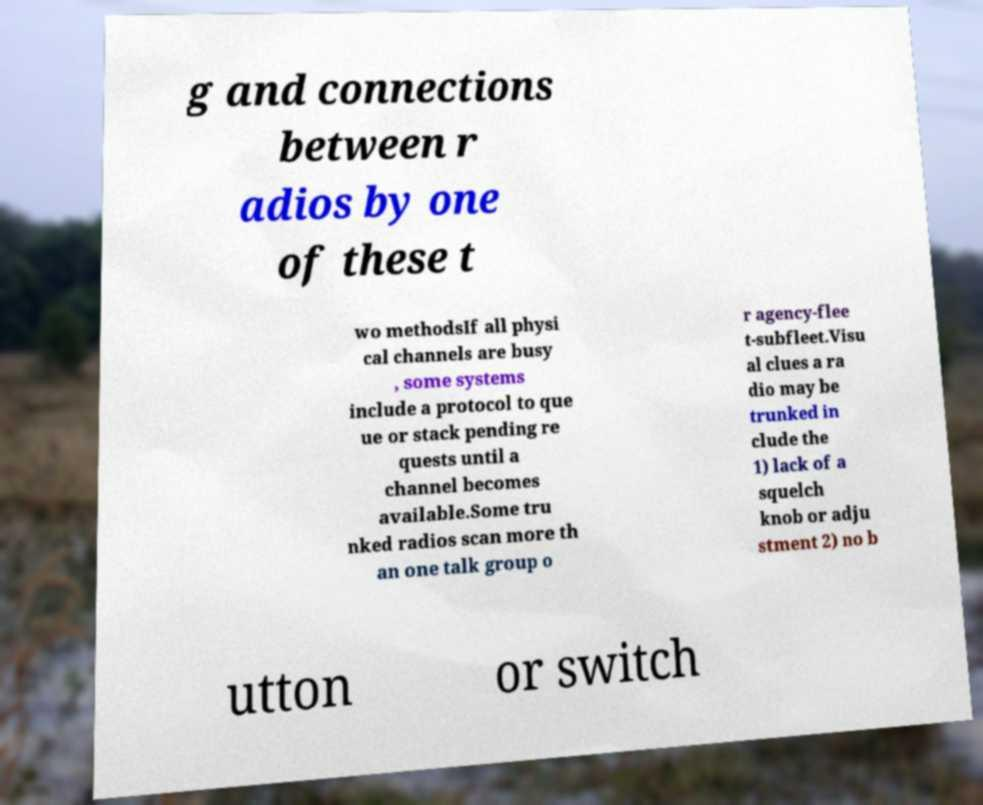Could you extract and type out the text from this image? g and connections between r adios by one of these t wo methodsIf all physi cal channels are busy , some systems include a protocol to que ue or stack pending re quests until a channel becomes available.Some tru nked radios scan more th an one talk group o r agency-flee t-subfleet.Visu al clues a ra dio may be trunked in clude the 1) lack of a squelch knob or adju stment 2) no b utton or switch 